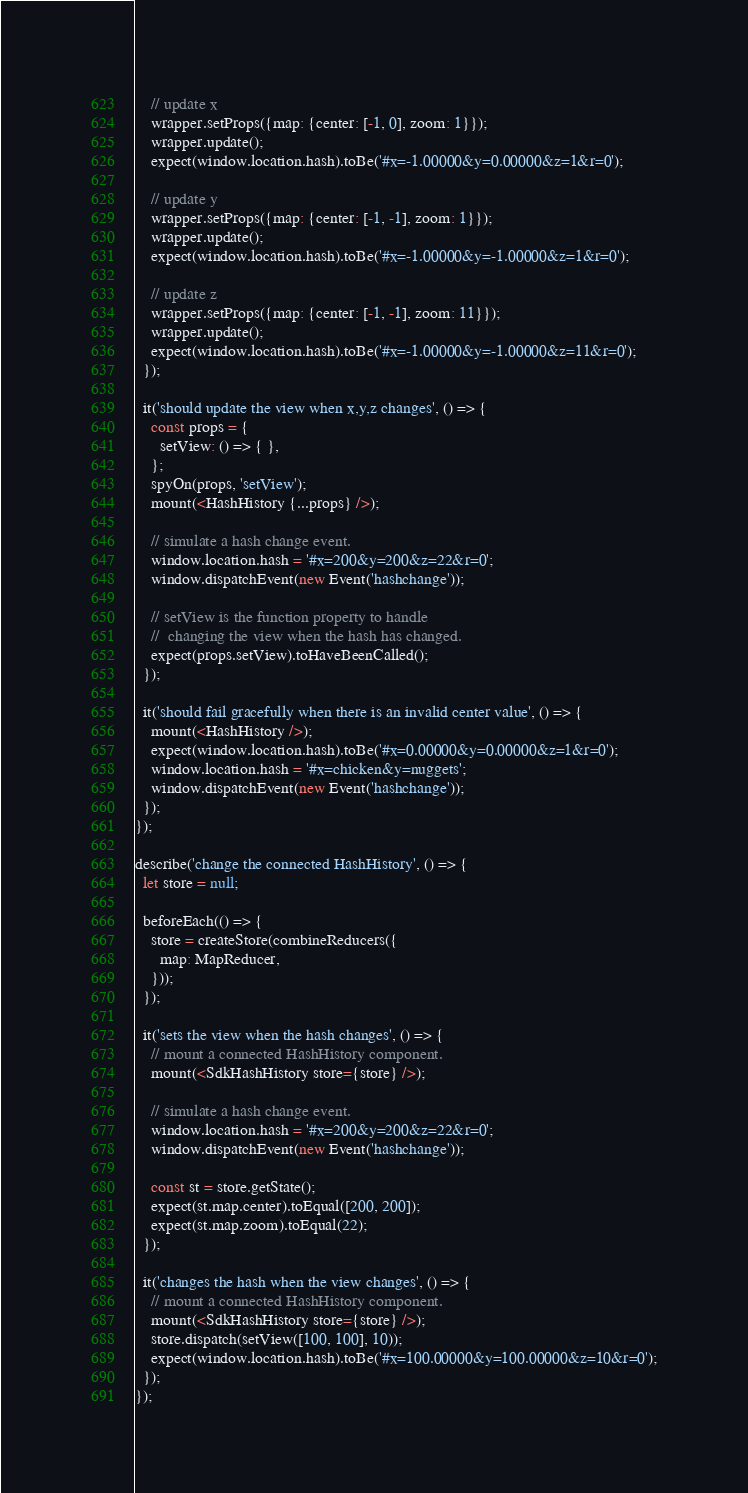<code> <loc_0><loc_0><loc_500><loc_500><_JavaScript_>    // update x
    wrapper.setProps({map: {center: [-1, 0], zoom: 1}});
    wrapper.update();
    expect(window.location.hash).toBe('#x=-1.00000&y=0.00000&z=1&r=0');

    // update y
    wrapper.setProps({map: {center: [-1, -1], zoom: 1}});
    wrapper.update();
    expect(window.location.hash).toBe('#x=-1.00000&y=-1.00000&z=1&r=0');

    // update z
    wrapper.setProps({map: {center: [-1, -1], zoom: 11}});
    wrapper.update();
    expect(window.location.hash).toBe('#x=-1.00000&y=-1.00000&z=11&r=0');
  });

  it('should update the view when x,y,z changes', () => {
    const props = {
      setView: () => { },
    };
    spyOn(props, 'setView');
    mount(<HashHistory {...props} />);

    // simulate a hash change event.
    window.location.hash = '#x=200&y=200&z=22&r=0';
    window.dispatchEvent(new Event('hashchange'));

    // setView is the function property to handle
    //  changing the view when the hash has changed.
    expect(props.setView).toHaveBeenCalled();
  });

  it('should fail gracefully when there is an invalid center value', () => {
    mount(<HashHistory />);
    expect(window.location.hash).toBe('#x=0.00000&y=0.00000&z=1&r=0');
    window.location.hash = '#x=chicken&y=nuggets';
    window.dispatchEvent(new Event('hashchange'));
  });
});

describe('change the connected HashHistory', () => {
  let store = null;

  beforeEach(() => {
    store = createStore(combineReducers({
      map: MapReducer,
    }));
  });

  it('sets the view when the hash changes', () => {
    // mount a connected HashHistory component.
    mount(<SdkHashHistory store={store} />);

    // simulate a hash change event.
    window.location.hash = '#x=200&y=200&z=22&r=0';
    window.dispatchEvent(new Event('hashchange'));

    const st = store.getState();
    expect(st.map.center).toEqual([200, 200]);
    expect(st.map.zoom).toEqual(22);
  });

  it('changes the hash when the view changes', () => {
    // mount a connected HashHistory component.
    mount(<SdkHashHistory store={store} />);
    store.dispatch(setView([100, 100], 10));
    expect(window.location.hash).toBe('#x=100.00000&y=100.00000&z=10&r=0');
  });
});
</code> 